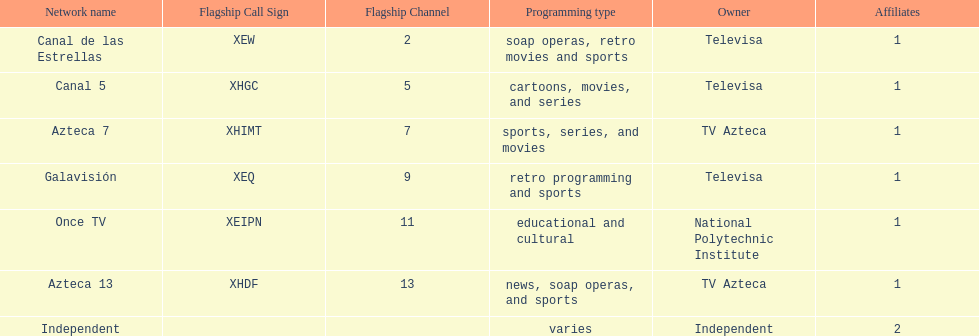How many networks does televisa own? 3. 